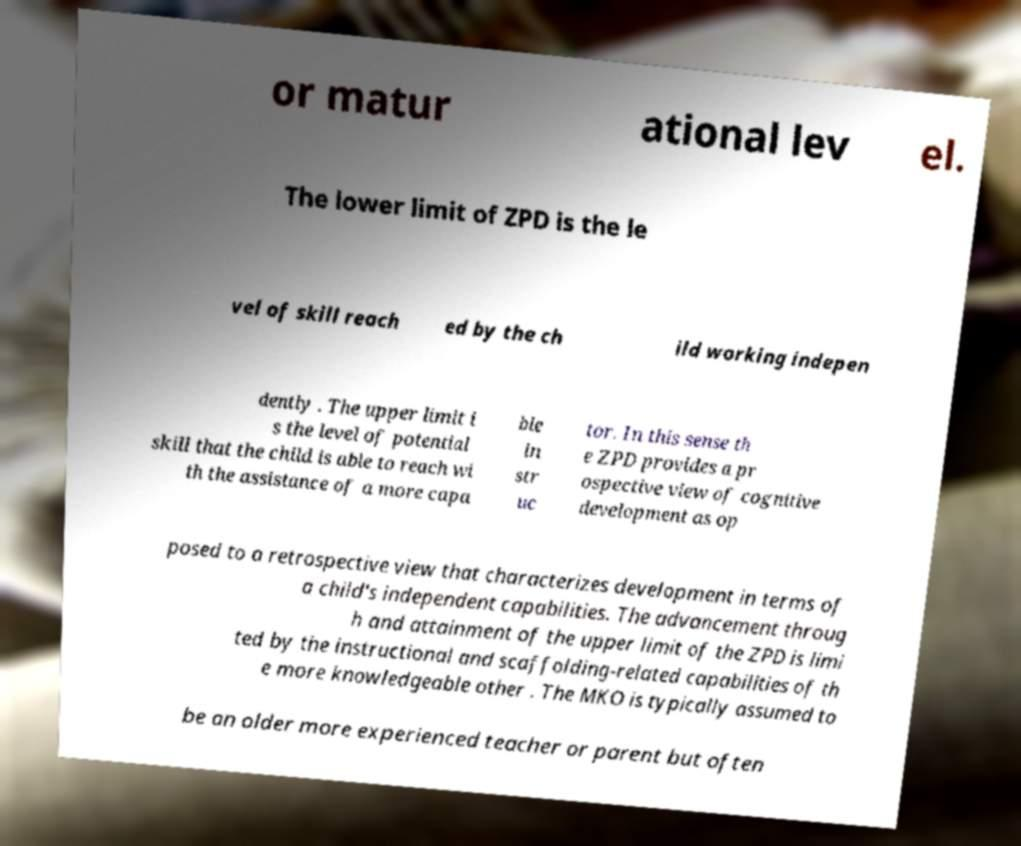There's text embedded in this image that I need extracted. Can you transcribe it verbatim? or matur ational lev el. The lower limit of ZPD is the le vel of skill reach ed by the ch ild working indepen dently . The upper limit i s the level of potential skill that the child is able to reach wi th the assistance of a more capa ble in str uc tor. In this sense th e ZPD provides a pr ospective view of cognitive development as op posed to a retrospective view that characterizes development in terms of a child's independent capabilities. The advancement throug h and attainment of the upper limit of the ZPD is limi ted by the instructional and scaffolding-related capabilities of th e more knowledgeable other . The MKO is typically assumed to be an older more experienced teacher or parent but often 